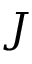<formula> <loc_0><loc_0><loc_500><loc_500>J</formula> 